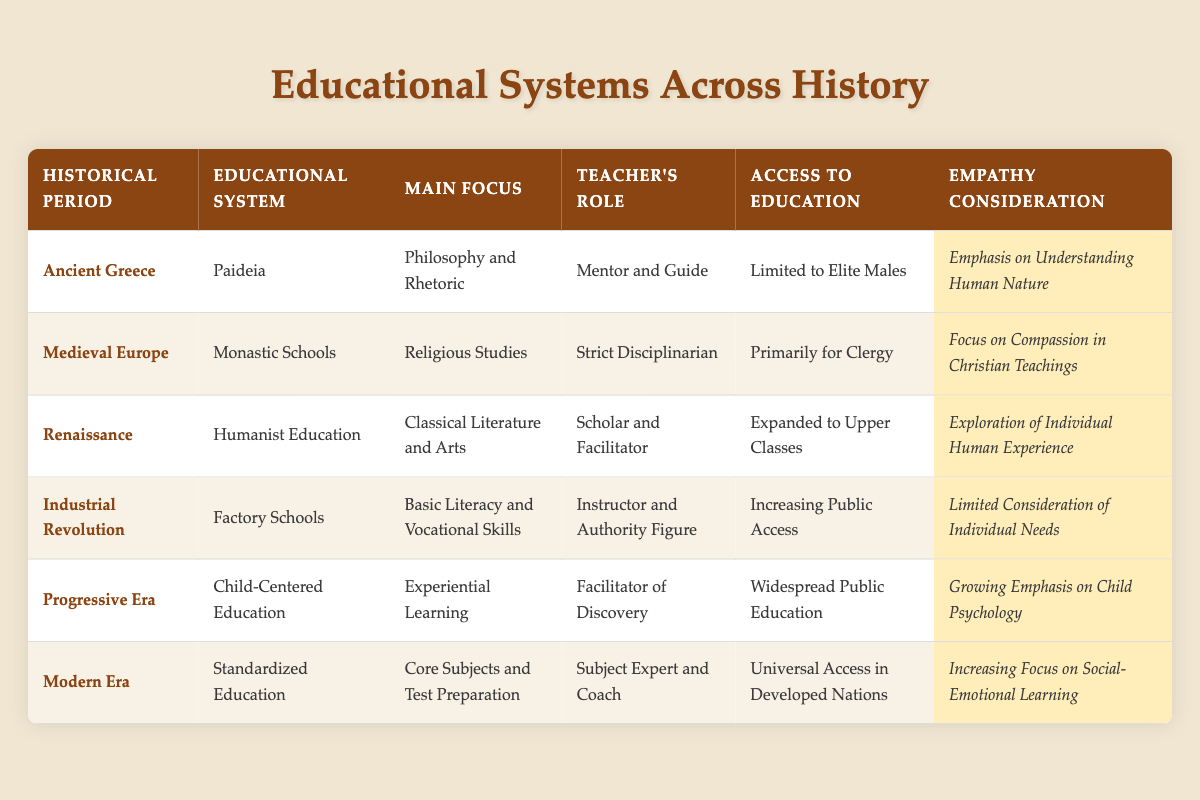What was the main focus of education in Ancient Greece? According to the table, the main focus of education in Ancient Greece was "Philosophy and Rhetoric." This is directly listed under the "Main Focus" column for the "Ancient Greece" row.
Answer: Philosophy and Rhetoric Was access to education during the Renaissance only for the elite? The table indicates that access to education during the Renaissance was "Expanded to Upper Classes." This suggests that it was not limited to just the elite, so the answer is no.
Answer: No What is the role of the teacher in Factory Schools compared to Child-Centered Education? The table shows that the teacher's role in Factory Schools is "Instructor and Authority Figure," while in Child-Centered Education, the teacher acts as a "Facilitator of Discovery." The difference highlights a shift from authority to more guidance-oriented teaching.
Answer: Instructor and Authority Figure vs. Facilitator of Discovery Which educational system had the highest consideration for empathy, and what does it emphasize? The table indicates that "Child-Centered Education" from the Progressive Era, and "Standardized Education" from the Modern Era both had high empathy considerations, emphasizing "Growing Emphasis on Child Psychology" and "Increasing Focus on Social-Emotional Learning," respectively. Comparing both, the Progressive Era emphasizes psychological aspects related to children, while the Modern Era focuses on social-emotional learning.
Answer: Child-Centered Education emphasizes Growing Emphasis on Child Psychology How many different educational systems are mentioned in the table, and which one focused on literacy and vocational skills? The table lists a total of six educational systems: Paideia, Monastic Schools, Humanist Education, Factory Schools, Child-Centered Education, and Standardized Education. The one that focused on literacy and vocational skills is "Factory Schools." Therefore, there are 6 educational systems, and the relevant one is Factory Schools.
Answer: There are 6 educational systems; Factory Schools focused on literacy and vocational skills 